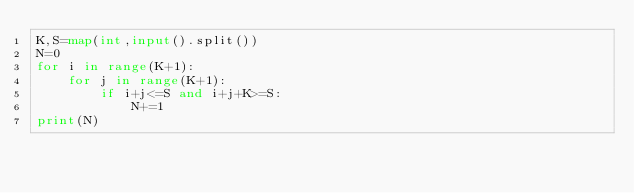<code> <loc_0><loc_0><loc_500><loc_500><_Python_>K,S=map(int,input().split())
N=0
for i in range(K+1):
    for j in range(K+1):
        if i+j<=S and i+j+K>=S:
            N+=1
print(N)</code> 